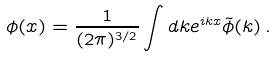Convert formula to latex. <formula><loc_0><loc_0><loc_500><loc_500>\phi ( x ) = \frac { 1 } { ( 2 \pi ) ^ { 3 / 2 } } \int d k e ^ { i k x } \tilde { \phi } ( k ) \, .</formula> 